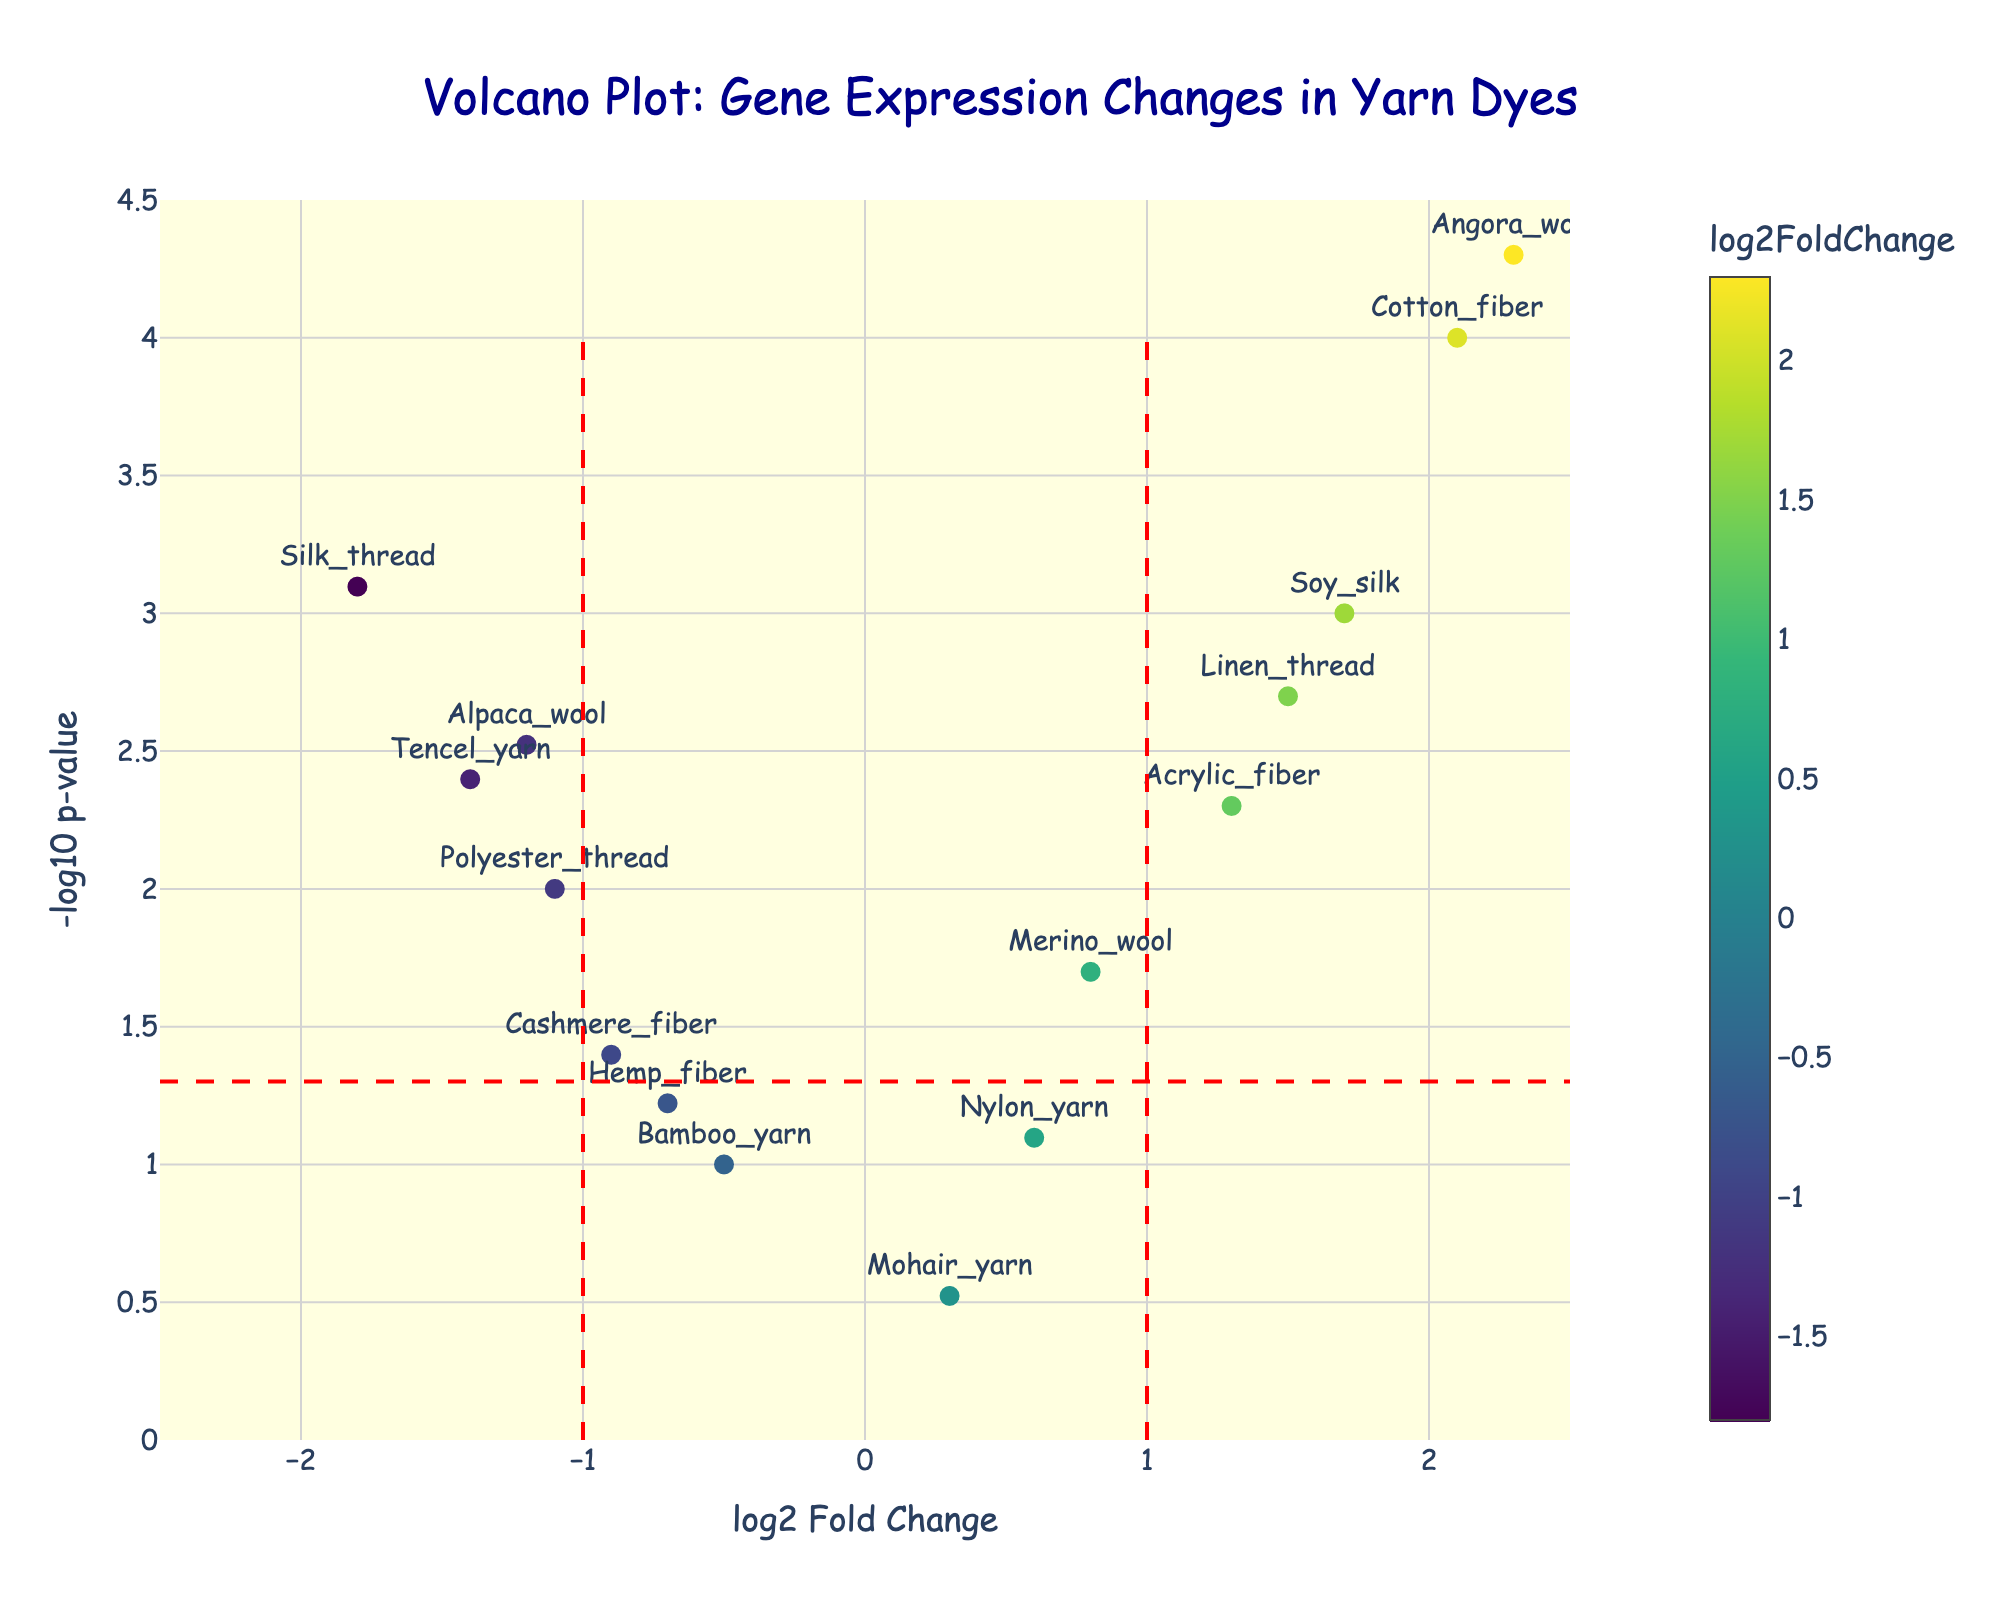What is the title of the plot? The title of the plot is usually placed at the top center. Here, it reads "Volcano Plot: Gene Expression Changes in Yarn Dyes".
Answer: Volcano Plot: Gene Expression Changes in Yarn Dyes Which gene has the highest log2 fold change? We need to look for the data point on the x-axis with the highest positive value. The highest log2 fold change is for the gene Angora_wool with a value of 2.3.
Answer: Angora_wool Which gene has the lowest p-value? The lowest p-value corresponds to the highest point on the y-axis which represents -log10(pValue). The topmost data point is Angora_wool with a p-value denoted by -log10(pValue).
Answer: Angora_wool How many genes show significant changes in expression (p-value < 0.05)? We identify the points above the horizontal red line. Counting them, we get Alpaca_wool, Merino_wool, Cotton_fiber, Acrylic_fiber, Silk_thread, Linen_thread, Angora_wool, Soy_silk, Tencel_yarn, and Polyester_thread. There are 10 genes.
Answer: 10 Which gene has the lowest log2 fold change? We identify the data point on the x-axis with the lowest negative value. The lowest log2 fold change is for the gene Silk_thread with a value of -1.8.
Answer: Silk_thread Which gene is closest to the origin? The origin is at (0,0). The gene closest to this point should have the smallest combination of log2 fold change and -log10(pValue). Mohair_yarn with values (0.3,0.3) is the closest.
Answer: Mohair_yarn Between Silk_thread and Linen_thread, which one has a smaller p-value? By comparing the y-values for Silk_thread and Linen_thread (since -log10(pValue) increases as p-value decreases), Silk_thread has a y-value of approximately 3.1 while Linen_thread's is around 3.0. Thus, Silk_thread has a smaller p-value.
Answer: Silk_thread What is the log2 fold change range visible in the plot? The x-axis displays the range of log2 fold change. The minimum value is around -2.5, and the maximum is around 2.5.
Answer: -2.5 to 2.5 What colors are used to represent the log2 fold change? The markers are colored using a Viridis color scale, which typically ranges from purple, blue, green, to yellow.
Answer: Purple, blue, green, yellow Which gene with significant changes has the lowest -log10 p-value? Among the significant genes (above the red horizontal line), the one lowest on the y-axis is Cashmere_fiber.
Answer: Cashmere_fiber 